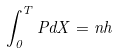<formula> <loc_0><loc_0><loc_500><loc_500>\int _ { 0 } ^ { T } P d X = n h</formula> 